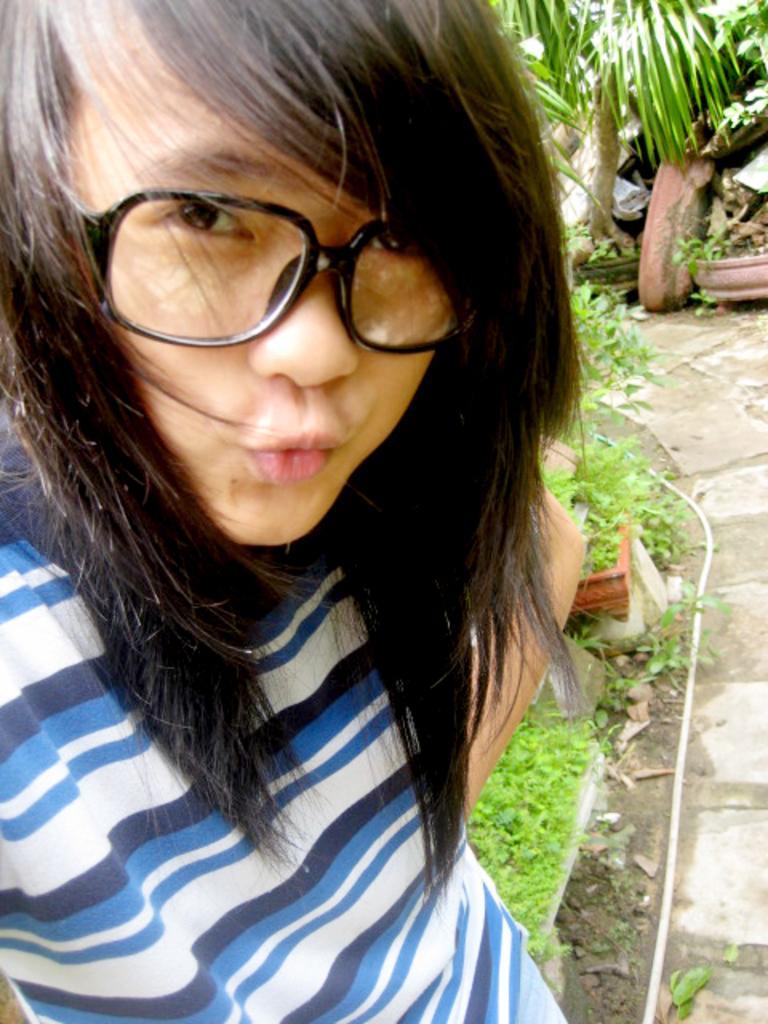In one or two sentences, can you explain what this image depicts? In this image, we can see a woman wearing glasses and watching. On the right side of the image, we can see walkway, pipes, plants, pots and few objects. 